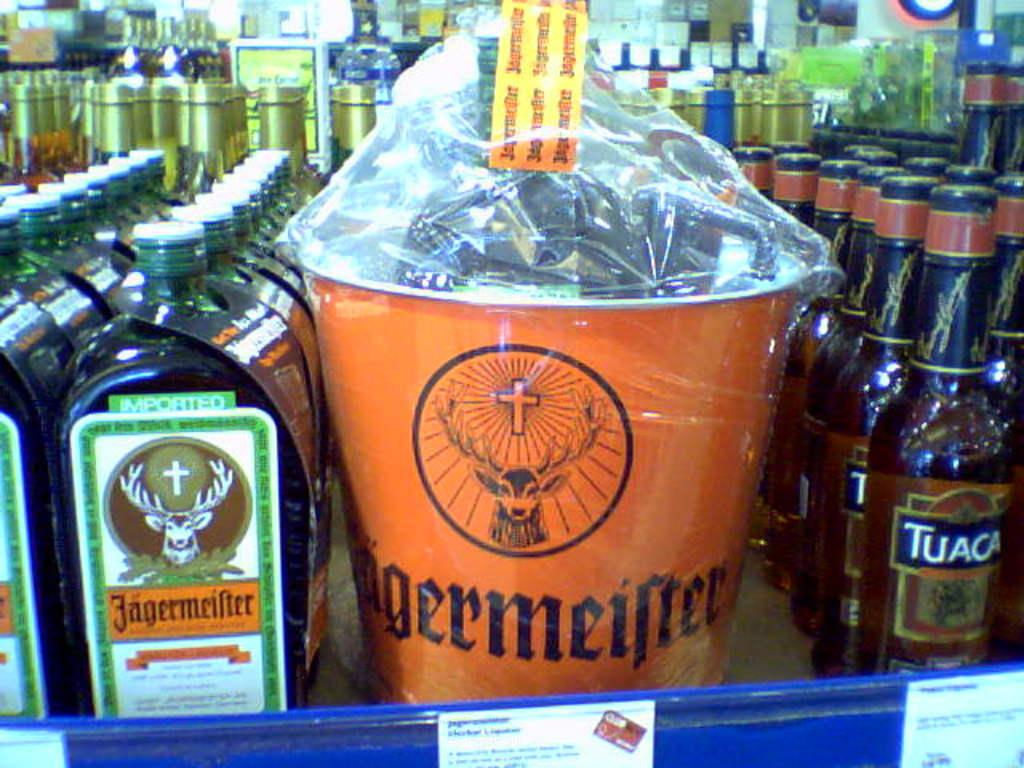<image>
Create a compact narrative representing the image presented. a bottle of jagermeister next to a can of it 